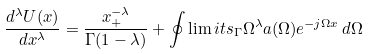<formula> <loc_0><loc_0><loc_500><loc_500>\frac { d ^ { \lambda } U ( x ) } { d x ^ { \lambda } } = \frac { x _ { + } ^ { - \lambda } } { \Gamma ( 1 - \lambda ) } + \oint \lim i t s _ { \Gamma } { \Omega } ^ { \lambda } a ( \Omega ) e ^ { - j \Omega x } \, d \Omega</formula> 